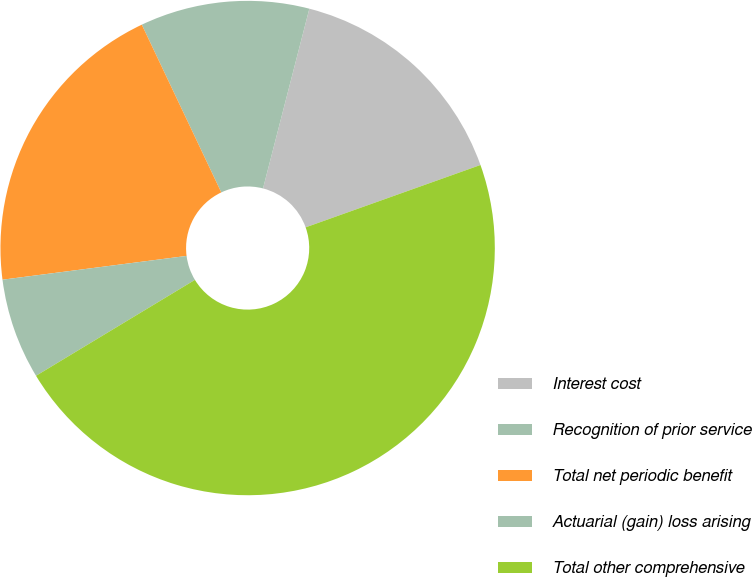<chart> <loc_0><loc_0><loc_500><loc_500><pie_chart><fcel>Interest cost<fcel>Recognition of prior service<fcel>Total net periodic benefit<fcel>Actuarial (gain) loss arising<fcel>Total other comprehensive<nl><fcel>15.53%<fcel>11.06%<fcel>20.0%<fcel>6.6%<fcel>46.81%<nl></chart> 